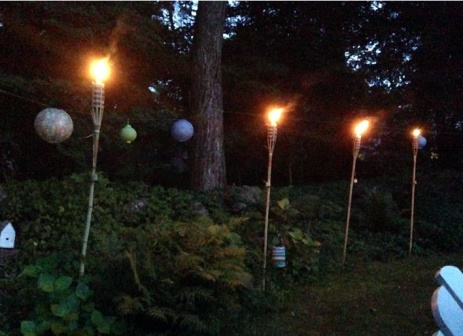What if the garden came to life at night? Describe that scenario. Imagine that as night falls, the garden in the image begins to stir with magical life. The plants, invigorated by the gentle glow of the tiki torches and lanterns, start to move and sway, their leaves rustling with unseen energy. Ferns extend and wrap around like gentle tendrils, hostas unfold to reveal glowing petals, and flowers that were hidden during the day bloom with ethereal light. Fireflies join the dance, their glimmers adding to the enchanting spectacle. Small woodland creatures emerge, drawn to the warmth of the flames, creating a scene that feels like a page out of a fairy tale. The garden, now a sanctuary of wonder and magic, becomes a refuge for those who believe in the unseen tales of the night. 